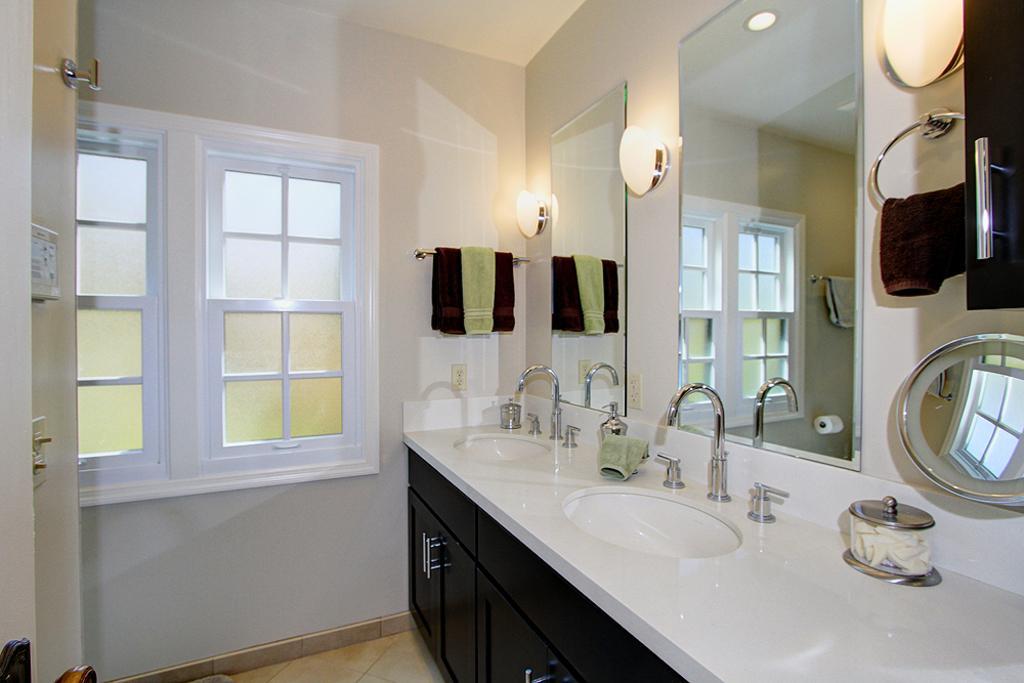Please provide a concise description of this image. On the right side there is a platform with cupboards. On that there are wash basins with taps. On the wall there are mirrors, lights and towels on hangers. Also there are windows. On the wall there is a hanger. On the mirrors there are reflection of towel on hanger, tissue and windows. 